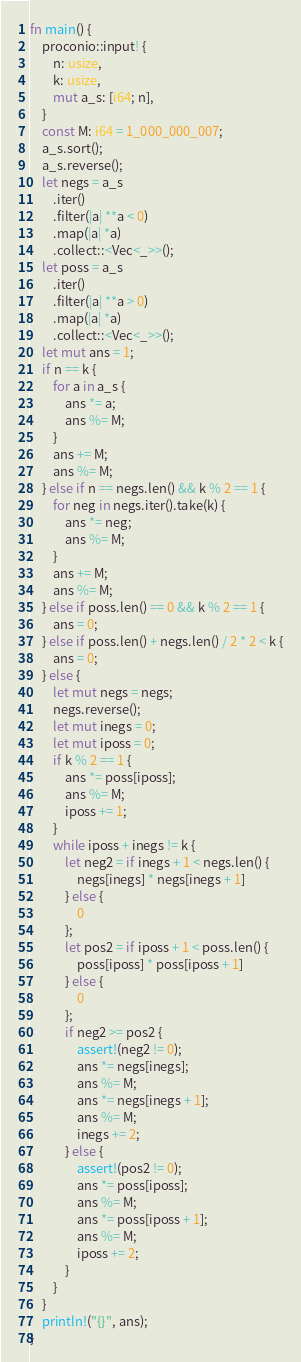<code> <loc_0><loc_0><loc_500><loc_500><_Rust_>fn main() {
    proconio::input! {
        n: usize,
        k: usize,
        mut a_s: [i64; n],
    }
    const M: i64 = 1_000_000_007;
    a_s.sort();
    a_s.reverse();
    let negs = a_s
        .iter()
        .filter(|a| **a < 0)
        .map(|a| *a)
        .collect::<Vec<_>>();
    let poss = a_s
        .iter()
        .filter(|a| **a > 0)
        .map(|a| *a)
        .collect::<Vec<_>>();
    let mut ans = 1;
    if n == k {
        for a in a_s {
            ans *= a;
            ans %= M;
        }
        ans += M;
        ans %= M;
    } else if n == negs.len() && k % 2 == 1 {
        for neg in negs.iter().take(k) {
            ans *= neg;
            ans %= M;
        }
        ans += M;
        ans %= M;
    } else if poss.len() == 0 && k % 2 == 1 {
        ans = 0;
    } else if poss.len() + negs.len() / 2 * 2 < k {
        ans = 0;
    } else {
        let mut negs = negs;
        negs.reverse();
        let mut inegs = 0;
        let mut iposs = 0;
        if k % 2 == 1 {
            ans *= poss[iposs];
            ans %= M;
            iposs += 1;
        }
        while iposs + inegs != k {
            let neg2 = if inegs + 1 < negs.len() {
                negs[inegs] * negs[inegs + 1]
            } else {
                0
            };
            let pos2 = if iposs + 1 < poss.len() {
                poss[iposs] * poss[iposs + 1]
            } else {
                0
            };
            if neg2 >= pos2 {
                assert!(neg2 != 0);
                ans *= negs[inegs];
                ans %= M;
                ans *= negs[inegs + 1];
                ans %= M;
                inegs += 2;
            } else {
                assert!(pos2 != 0);
                ans *= poss[iposs];
                ans %= M;
                ans *= poss[iposs + 1];
                ans %= M;
                iposs += 2;
            }
        }
    }
    println!("{}", ans);
}
</code> 